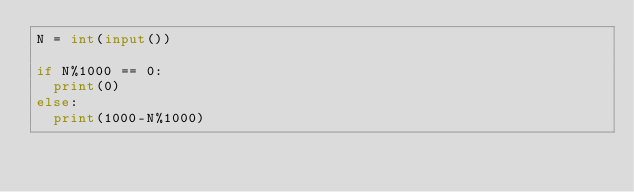Convert code to text. <code><loc_0><loc_0><loc_500><loc_500><_Python_>N = int(input())

if N%1000 == 0:
  print(0)
else:
  print(1000-N%1000)
 </code> 